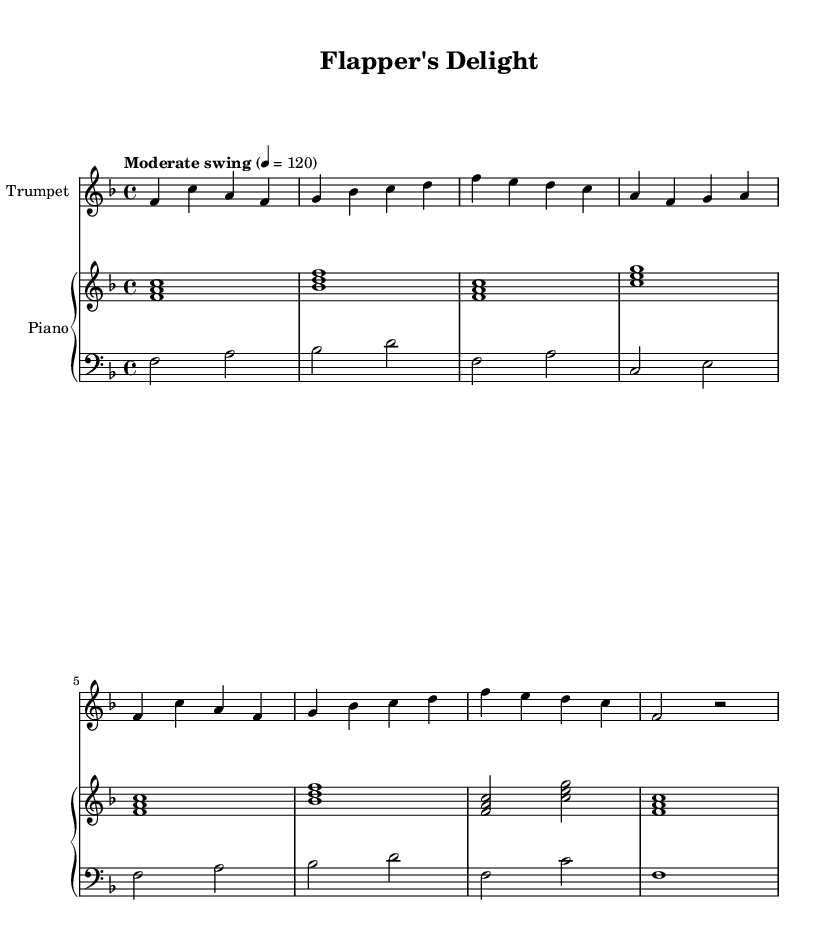What is the key signature of this music? The key signature is F major, which has one flat (B flat). You can identify the key signature by looking at the key signature section at the beginning of the staff, which shows one flat.
Answer: F major What is the time signature of this piece? The time signature is 4/4, meaning there are four beats in a measure and the quarter note gets one beat. This is indicated at the beginning of the score, right after the key signature.
Answer: 4/4 What tempo is indicated for this score? The tempo indication is "Moderate swing" at a speed of 120 beats per minute. This information is found above the staff, which indicates the desired feel and pacing of the piece.
Answer: Moderate swing 120 How many measures are in the trumpet part? The trumpet part consists of eight measures. This can be counted by looking at the vertical lines, which separate each measure, and counting them sequentially.
Answer: Eight What is the last note played by the trumpet? The last note played by the trumpet is a rest (notated as "r"). This indicates a pause in the playing, and it is found in the final measure of the part.
Answer: Rest Are there any repeated sections in the music? Yes, there are repeated sections in the music, specifically the first eight measures are repeated. This can be verified by comparing the musical content and finding identical patterns in the score.
Answer: Yes 